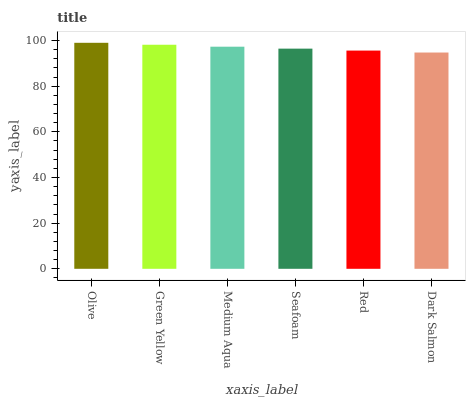Is Green Yellow the minimum?
Answer yes or no. No. Is Green Yellow the maximum?
Answer yes or no. No. Is Olive greater than Green Yellow?
Answer yes or no. Yes. Is Green Yellow less than Olive?
Answer yes or no. Yes. Is Green Yellow greater than Olive?
Answer yes or no. No. Is Olive less than Green Yellow?
Answer yes or no. No. Is Medium Aqua the high median?
Answer yes or no. Yes. Is Seafoam the low median?
Answer yes or no. Yes. Is Green Yellow the high median?
Answer yes or no. No. Is Green Yellow the low median?
Answer yes or no. No. 